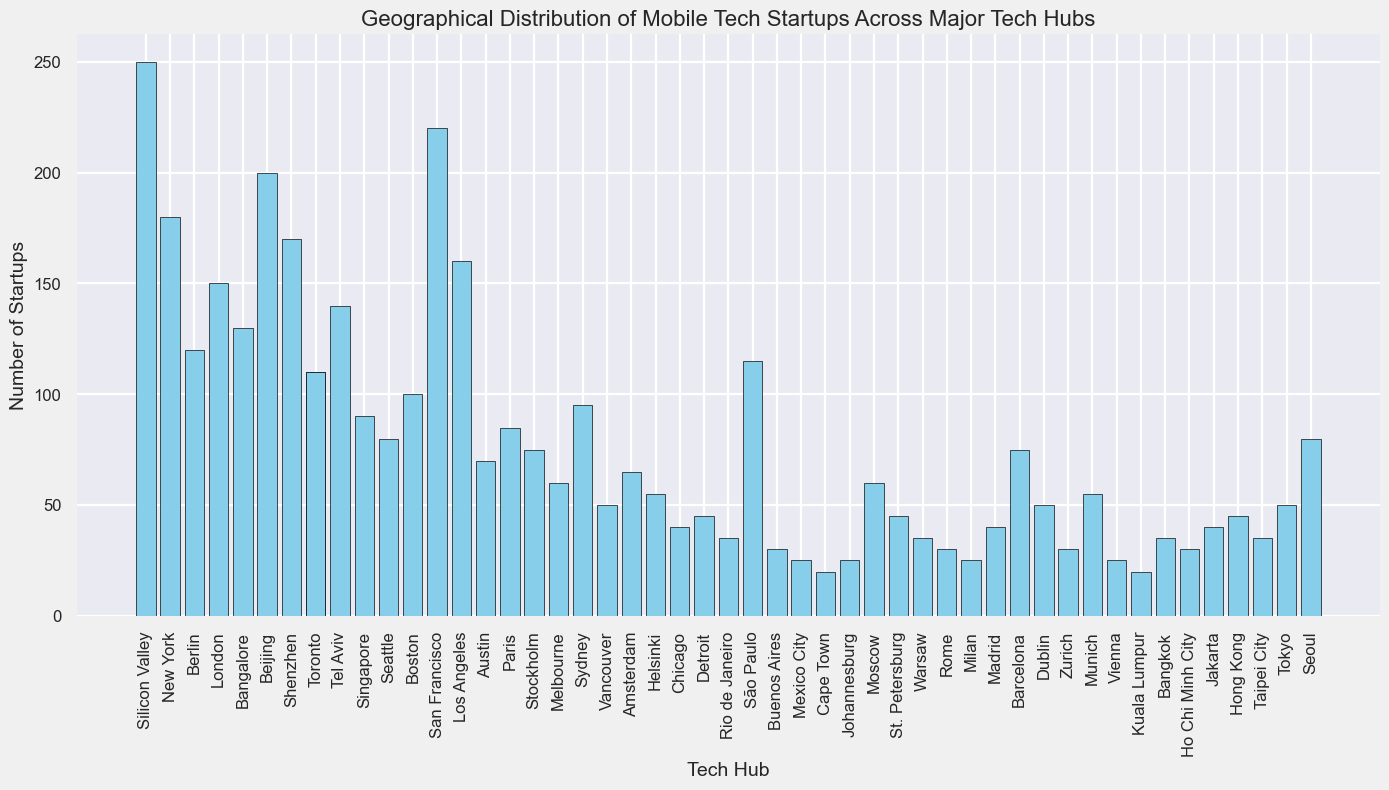Which tech hub has the highest number of mobile tech startups? Looking at the height of the bars, Silicon Valley has the tallest bar, indicating it has the highest number of startups.
Answer: Silicon Valley Which tech hub has more mobile tech startups: New York or Berlin? Comparing the bars for New York and Berlin, New York's bar is taller, which means it has more startups.
Answer: New York What is the sum of the number of startups in Shanghai and Tel Aviv? According to the figure, Shanghai has 170 startups and Tel Aviv has 140. Adding these gives 170 + 140.
Answer: 310 How many more startups does Silicon Valley have compared to Bangalore? Silicon Valley has 250 startups, and Bangalore has 130. Subtracting these, we get 250 - 130.
Answer: 120 Which tech hub has the lowest number of startups? Looking at the histogram, Johannesburg has the shortest bar, indicating the lowest number of startups.
Answer: Johannesburg Is the number of startups in Tokyo greater or less than the number of startups in Sydney? Comparing the heights of the bars for Tokyo and Sydney, Sydney has a taller bar, indicating it has more startups than Tokyo.
Answer: Less Are there more startups in Toronto or in Vancouver? Comparing the bars for Toronto and Vancouver, Toronto's bar is taller, which means it has more startups.
Answer: Toronto What is the average number of startups among Beijing, Shenzhen, and Auckland? The number of startups are 200 for Beijing, 170 for Shenzhen, and 90 for Auckland. Therefore, the average is (200 + 170 + 90) / 3 = 460 / 3.
Answer: 153.33 Among the tech hubs in Europe displayed in the figure, which one has the highest number of startups? From the European tech hubs listed (Berlin, London, Paris, Stockholm, Amsterdam, Helsinki, Barcelona, Dublin, Zurich, Munich, Vienna), London has the tallest bar indicating the highest number of startups.
Answer: London 